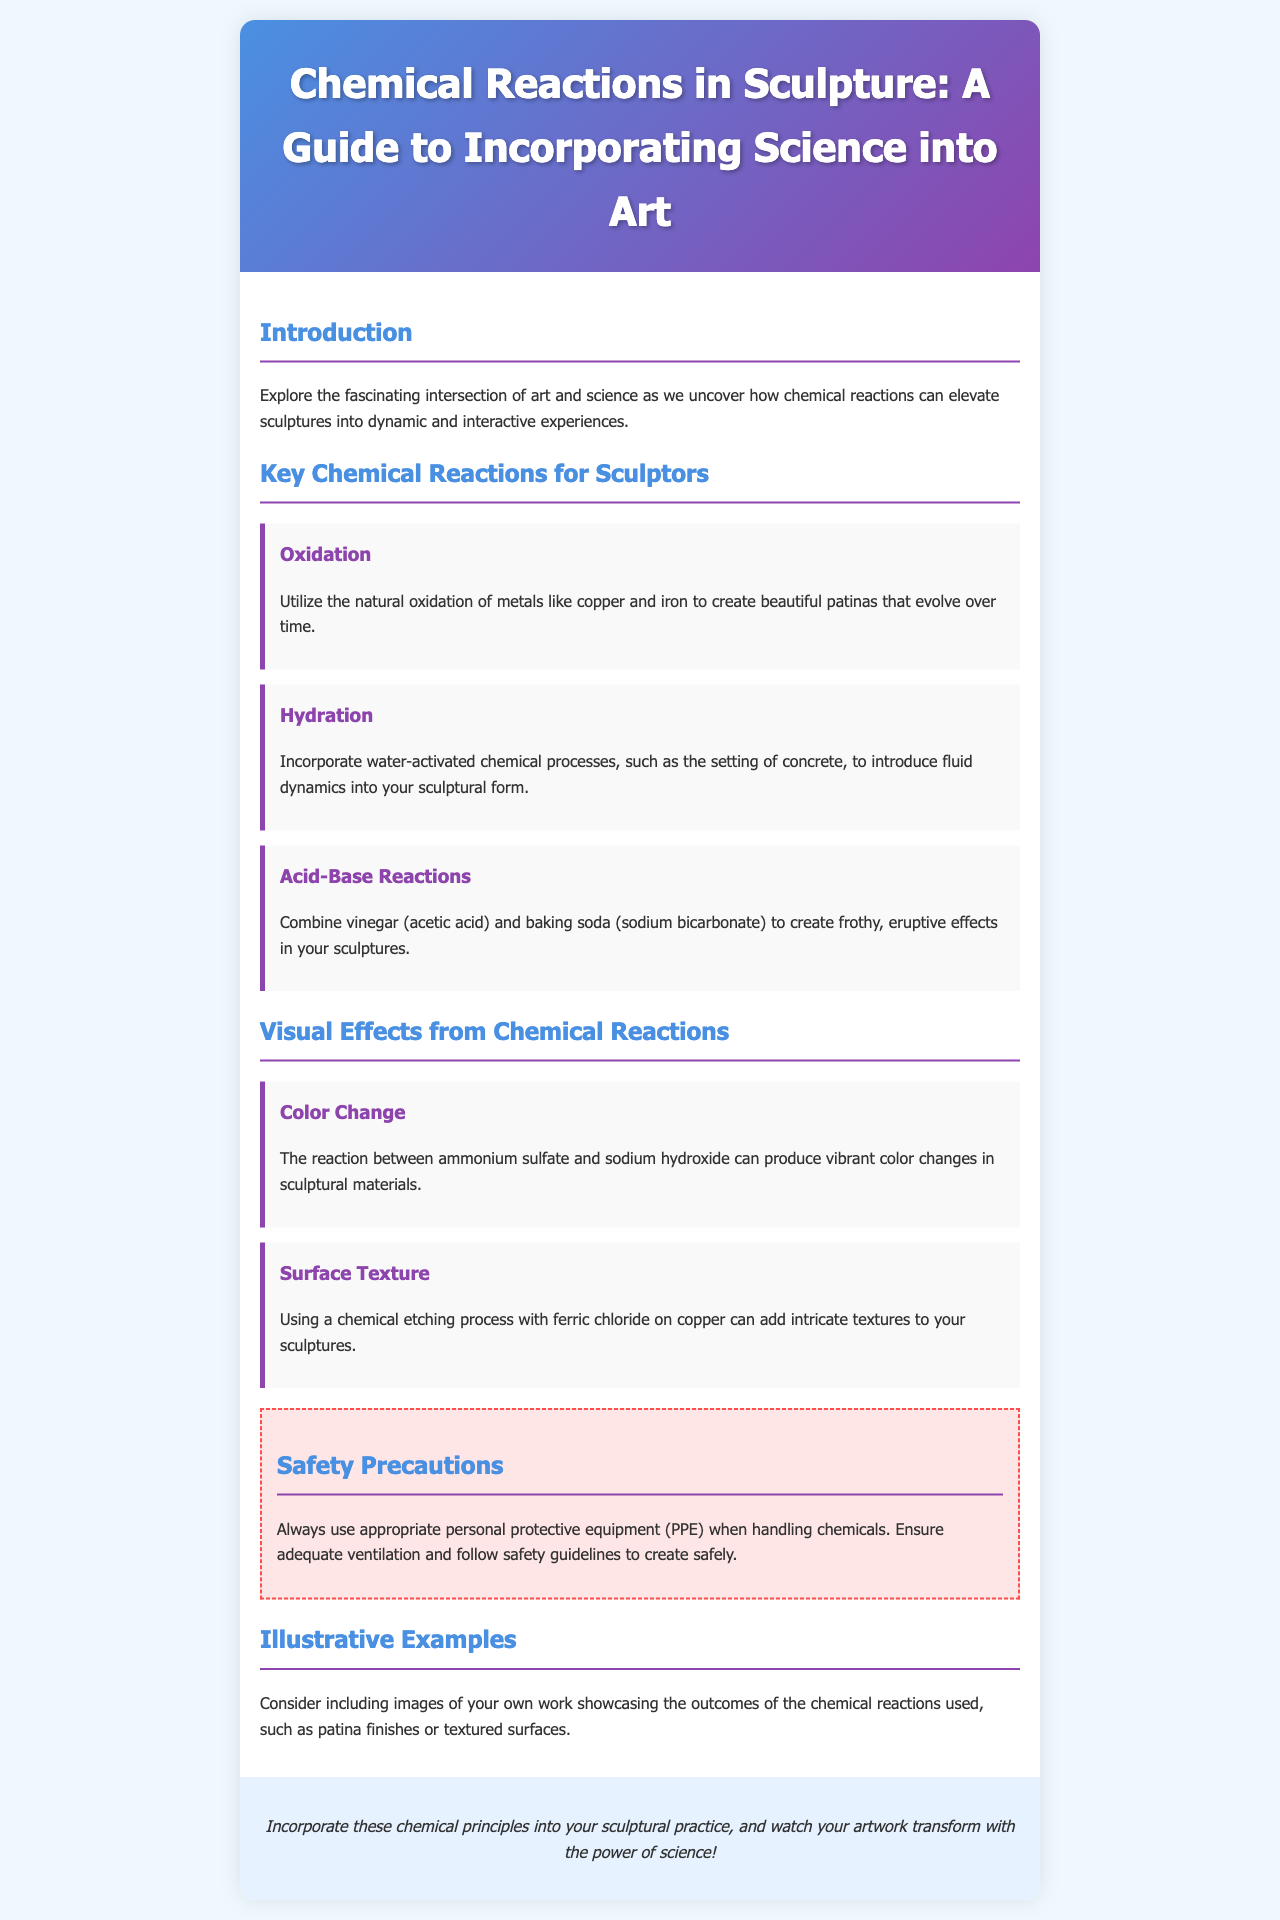What is the title of the brochure? The title of the brochure is prominently displayed at the top.
Answer: Chemical Reactions in Sculpture: A Guide to Incorporating Science into Art What is one of the key chemical reactions mentioned for sculptors? The document lists several reactions under the "Key Chemical Reactions for Sculptors" section.
Answer: Oxidation What color change is associated with ammonium sulfate and sodium hydroxide? This effect is detailed in the "Visual Effects from Chemical Reactions" section.
Answer: Vibrant color changes What is a safety precaution mentioned in the brochure? Safety measures are outlined in the "Safety Precautions" section.
Answer: Use appropriate personal protective equipment (PPE) How many key chemical reactions are listed in the brochure? The document specifically mentions three key reactions.
Answer: Three 